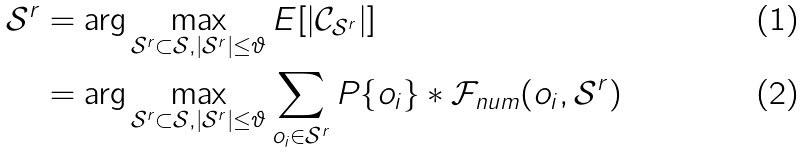Convert formula to latex. <formula><loc_0><loc_0><loc_500><loc_500>\mathcal { S } ^ { r } & = \arg \max _ { \mathcal { S } ^ { r } \subset \mathcal { S } , | \mathcal { S } ^ { r } | \leq \vartheta } E [ | \mathcal { C } _ { \mathcal { S } ^ { r } } | ] \\ & = \arg \max _ { \mathcal { S } ^ { r } \subset \mathcal { S } , | \mathcal { S } ^ { r } | \leq \vartheta } \sum _ { o _ { i } \in \mathcal { S } ^ { r } } P \{ o _ { i } \} * \mathcal { F } _ { n u m } ( o _ { i } , \mathcal { S } ^ { r } )</formula> 